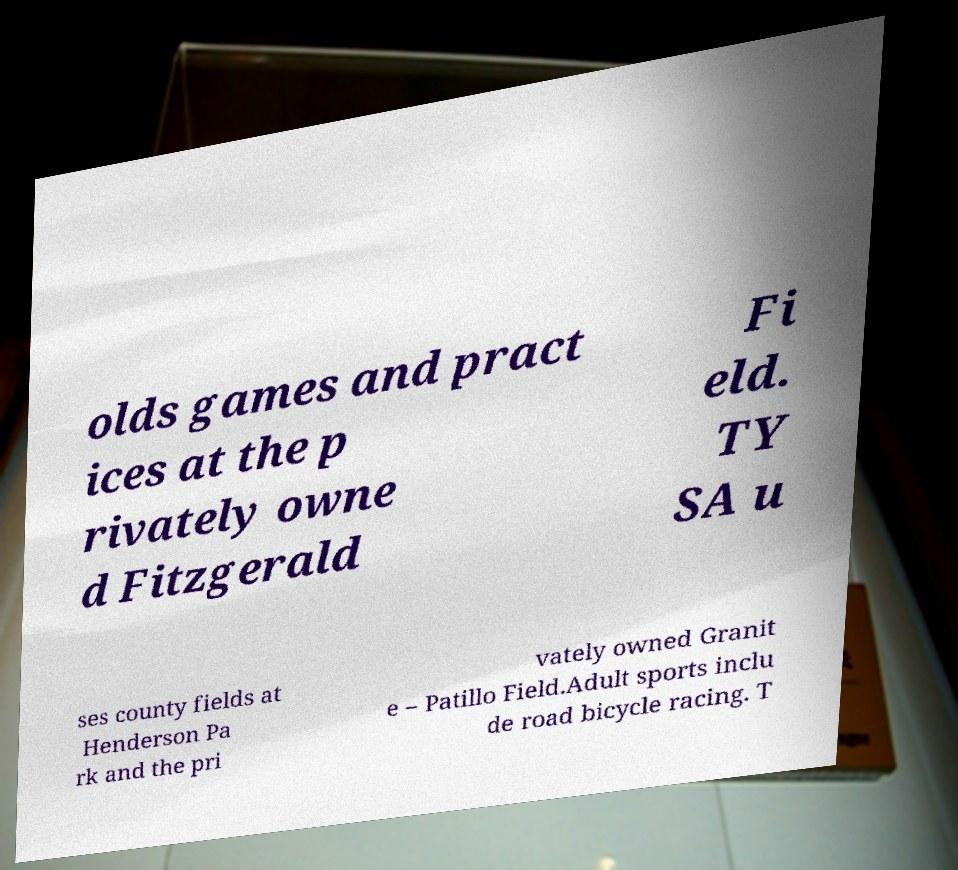What messages or text are displayed in this image? I need them in a readable, typed format. olds games and pract ices at the p rivately owne d Fitzgerald Fi eld. TY SA u ses county fields at Henderson Pa rk and the pri vately owned Granit e – Patillo Field.Adult sports inclu de road bicycle racing. T 